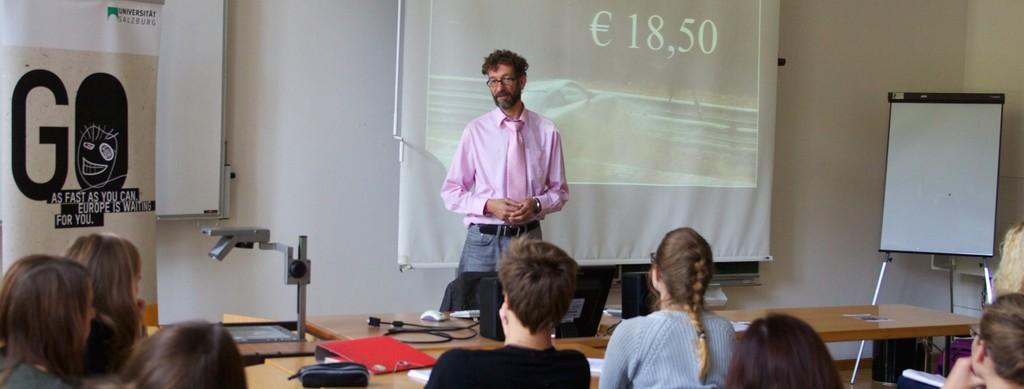What is the color of the wall in the image? The wall in the image is white. What can be seen hanging on the wall? There is a banner in the image. What is the main object in the center of the image? There is a screen in the image. What is present on the wall next to the screen? There is a board in the image. How are the people in the image positioned? There are people sitting on chairs in the image. What is the source of light in the image? There is a lamp in the image. What is on the table in the image? There is a table in the image with laptops, a keyboard, and a mouse on it. What is the topic of the discussion taking place during the week in the image? There is no discussion taking place in the image, nor is there any reference to a specific week. 